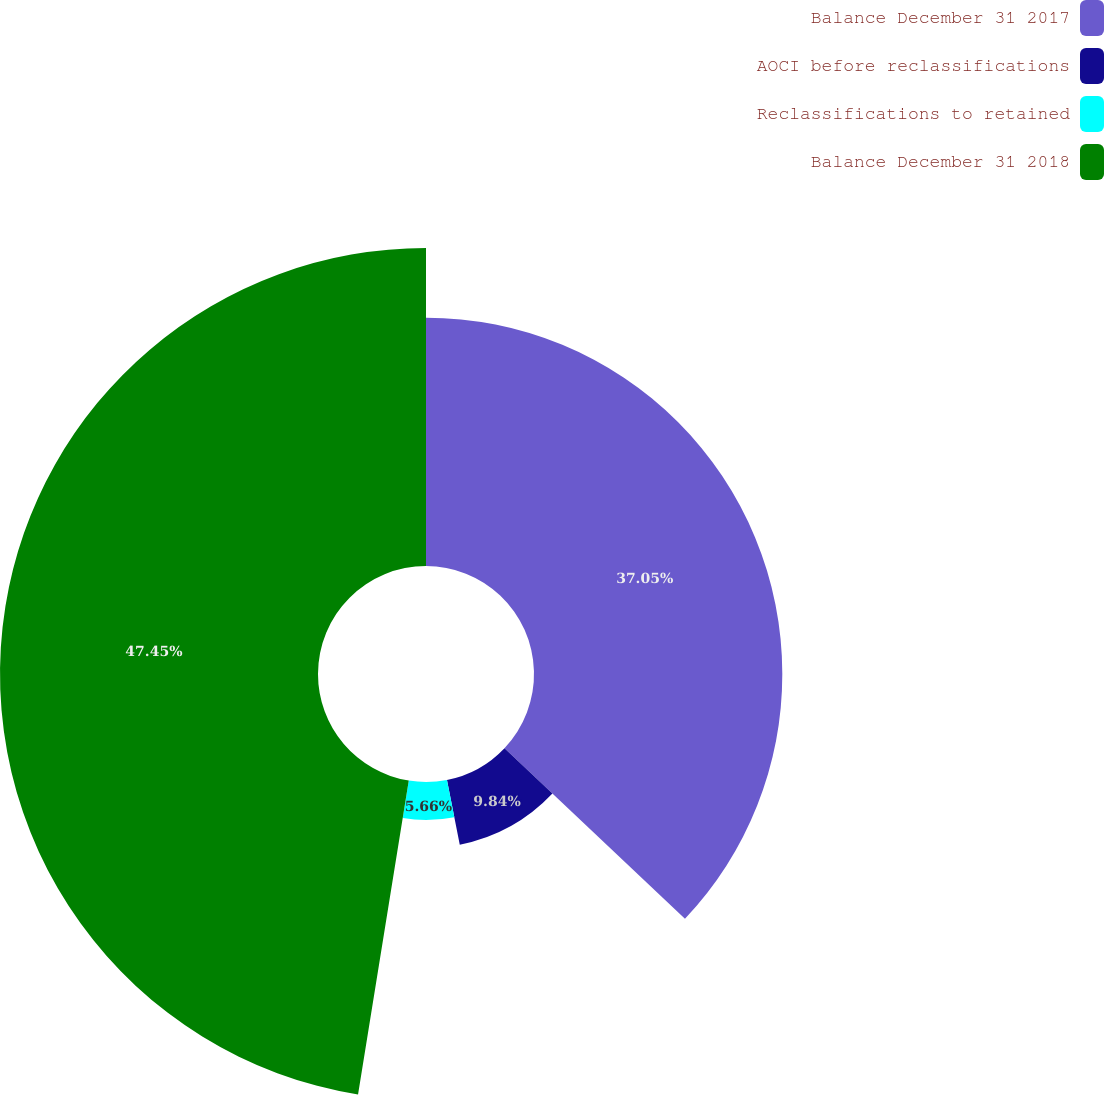<chart> <loc_0><loc_0><loc_500><loc_500><pie_chart><fcel>Balance December 31 2017<fcel>AOCI before reclassifications<fcel>Reclassifications to retained<fcel>Balance December 31 2018<nl><fcel>37.05%<fcel>9.84%<fcel>5.66%<fcel>47.45%<nl></chart> 